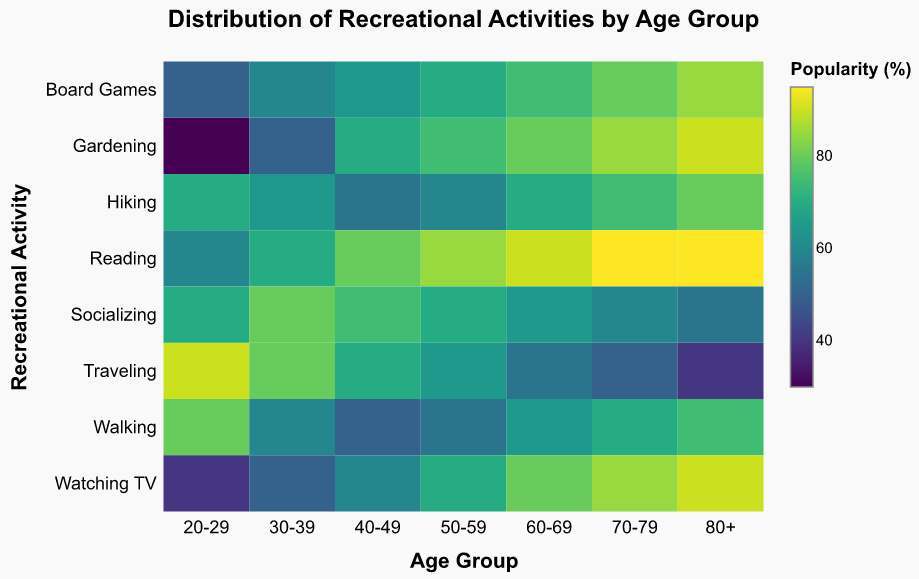Which age group enjoys Reading the most? To determine which age group enjoys Reading the most, look for the highest value in the "Reading" row. The maximum value is 95, and it corresponds to the age groups 70-79 and 80+.
Answer: 70-79 and 80+ What recreational activity is most popular among the 20-29 age group? To find the most popular activity for the 20-29 age group, look for the highest value in the 20-29 column. The highest value is 90 for "Traveling."
Answer: Traveling How does the popularity of Walking change from the youngest age group (20-29) to the oldest (80+)? Compare the values for Walking between the 20-29 age group and the 80+ age group. For 20-29, the value is 80, and for 80+, the value is 75. There is a slight decrease of 5 percentage points.
Answer: Slightly decreases Is Gardening more popular among people aged 50-59 or those aged 60-69? Compare the values for Gardening in the 50-59 and 60-69 age groups. For 50-59, the value is 75, and for 60-69, the value is 80.
Answer: 60-69 Which recreational activity has the smallest change in popularity across all age groups? To find the activity with the smallest change in popularity, examine the numerical range (difference between the highest and lowest values) for each activity. "Hiking" has the smallest range of 25 (from 55 to 80).
Answer: Hiking Which age group spends the most time Socializing? To determine the age group that spends the most time socializing, look for the highest value in the "Socializing" row. The highest value is 80 in the 30-39 age group.
Answer: 30-39 What is the average popularity of Traveling across all age groups? Sum the Traveling values for all age groups, then divide by the number of age groups: (90+80+70+65+55+50+40)/7 = 450/7 ≈ 64.29.
Answer: 64.29 Which activity becomes more popular as age increases, and by how much does its popularity increase from the youngest age group to the oldest? Examine each activity's trend across age groups to determine which becomes more popular. "Gardening" increases from 30 (20-29) to 90 (80+), a total increase of 60 percentage points.
Answer: Gardening, increase of 60 How does Watching TV's popularity compare between the 40-49 and 80+ age groups? Compare the values for Watching TV between the 40-49 and 80+ age groups. For 40-49, the value is 60, and for 80+, the value is 90.
Answer: 80+ is higher 